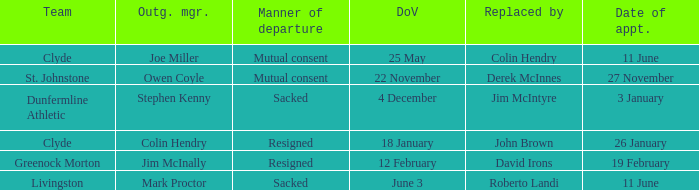Tell me the outgoing manager for 22 november date of vacancy Owen Coyle. Can you parse all the data within this table? {'header': ['Team', 'Outg. mgr.', 'Manner of departure', 'DoV', 'Replaced by', 'Date of appt.'], 'rows': [['Clyde', 'Joe Miller', 'Mutual consent', '25 May', 'Colin Hendry', '11 June'], ['St. Johnstone', 'Owen Coyle', 'Mutual consent', '22 November', 'Derek McInnes', '27 November'], ['Dunfermline Athletic', 'Stephen Kenny', 'Sacked', '4 December', 'Jim McIntyre', '3 January'], ['Clyde', 'Colin Hendry', 'Resigned', '18 January', 'John Brown', '26 January'], ['Greenock Morton', 'Jim McInally', 'Resigned', '12 February', 'David Irons', '19 February'], ['Livingston', 'Mark Proctor', 'Sacked', 'June 3', 'Roberto Landi', '11 June']]} 